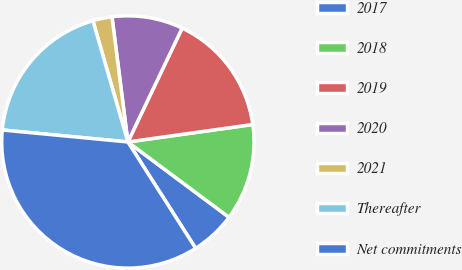Convert chart to OTSL. <chart><loc_0><loc_0><loc_500><loc_500><pie_chart><fcel>2017<fcel>2018<fcel>2019<fcel>2020<fcel>2021<fcel>Thereafter<fcel>Net commitments<nl><fcel>5.78%<fcel>12.4%<fcel>15.71%<fcel>9.09%<fcel>2.46%<fcel>19.02%<fcel>35.55%<nl></chart> 